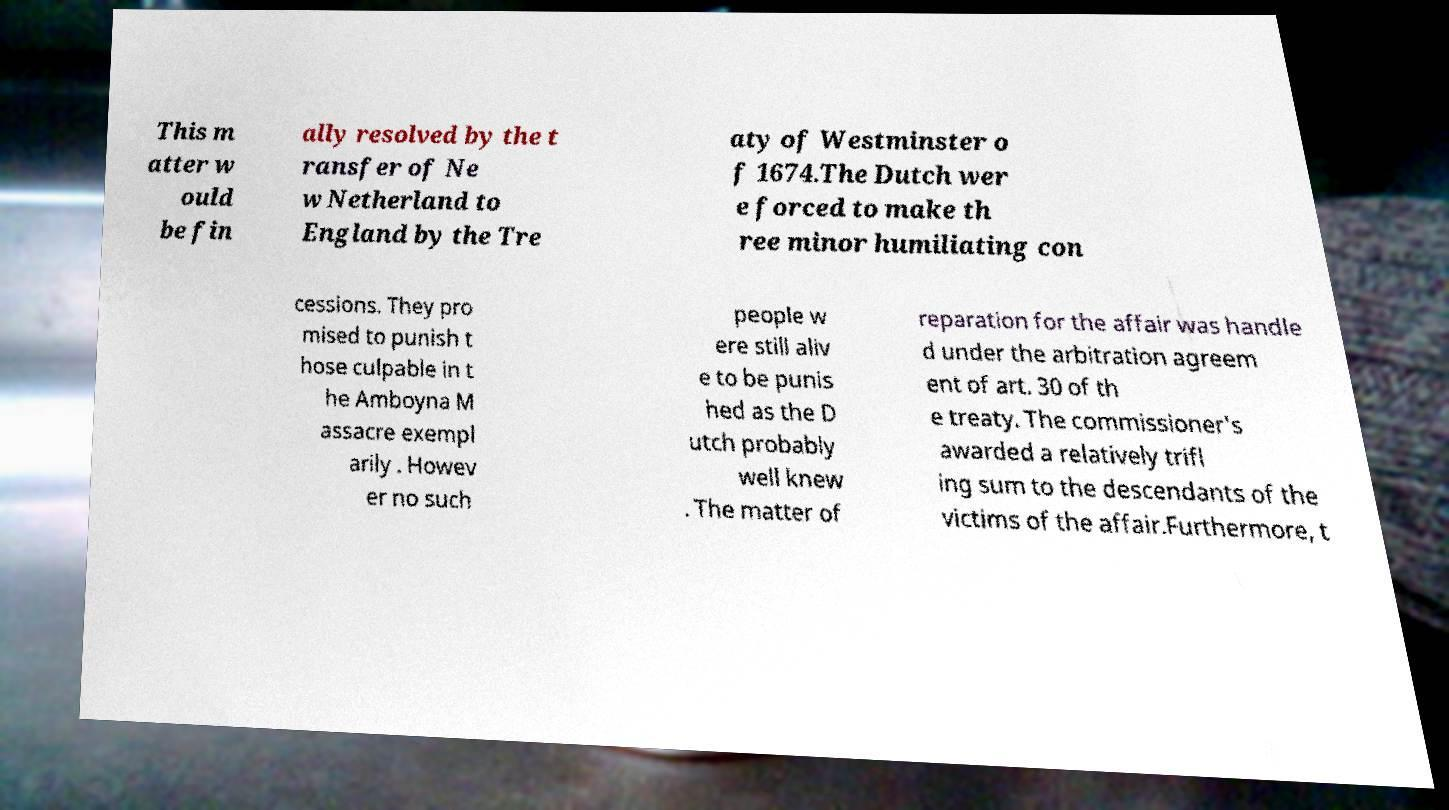I need the written content from this picture converted into text. Can you do that? This m atter w ould be fin ally resolved by the t ransfer of Ne w Netherland to England by the Tre aty of Westminster o f 1674.The Dutch wer e forced to make th ree minor humiliating con cessions. They pro mised to punish t hose culpable in t he Amboyna M assacre exempl arily . Howev er no such people w ere still aliv e to be punis hed as the D utch probably well knew . The matter of reparation for the affair was handle d under the arbitration agreem ent of art. 30 of th e treaty. The commissioner's awarded a relatively trifl ing sum to the descendants of the victims of the affair.Furthermore, t 